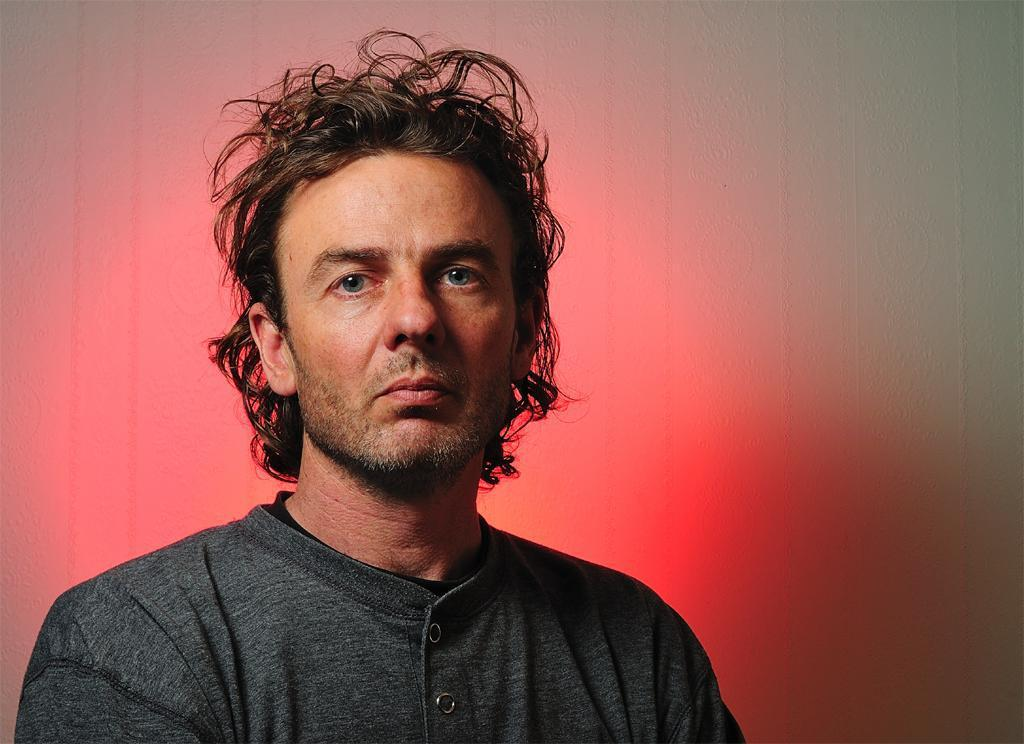Who is the main subject in the image? There is a man in the center of the image. What can be seen in the background of the image? There is a wall in the background of the image. How many trees are visible in the image? There are no trees visible in the image; it only features a man and a wall in the background. 